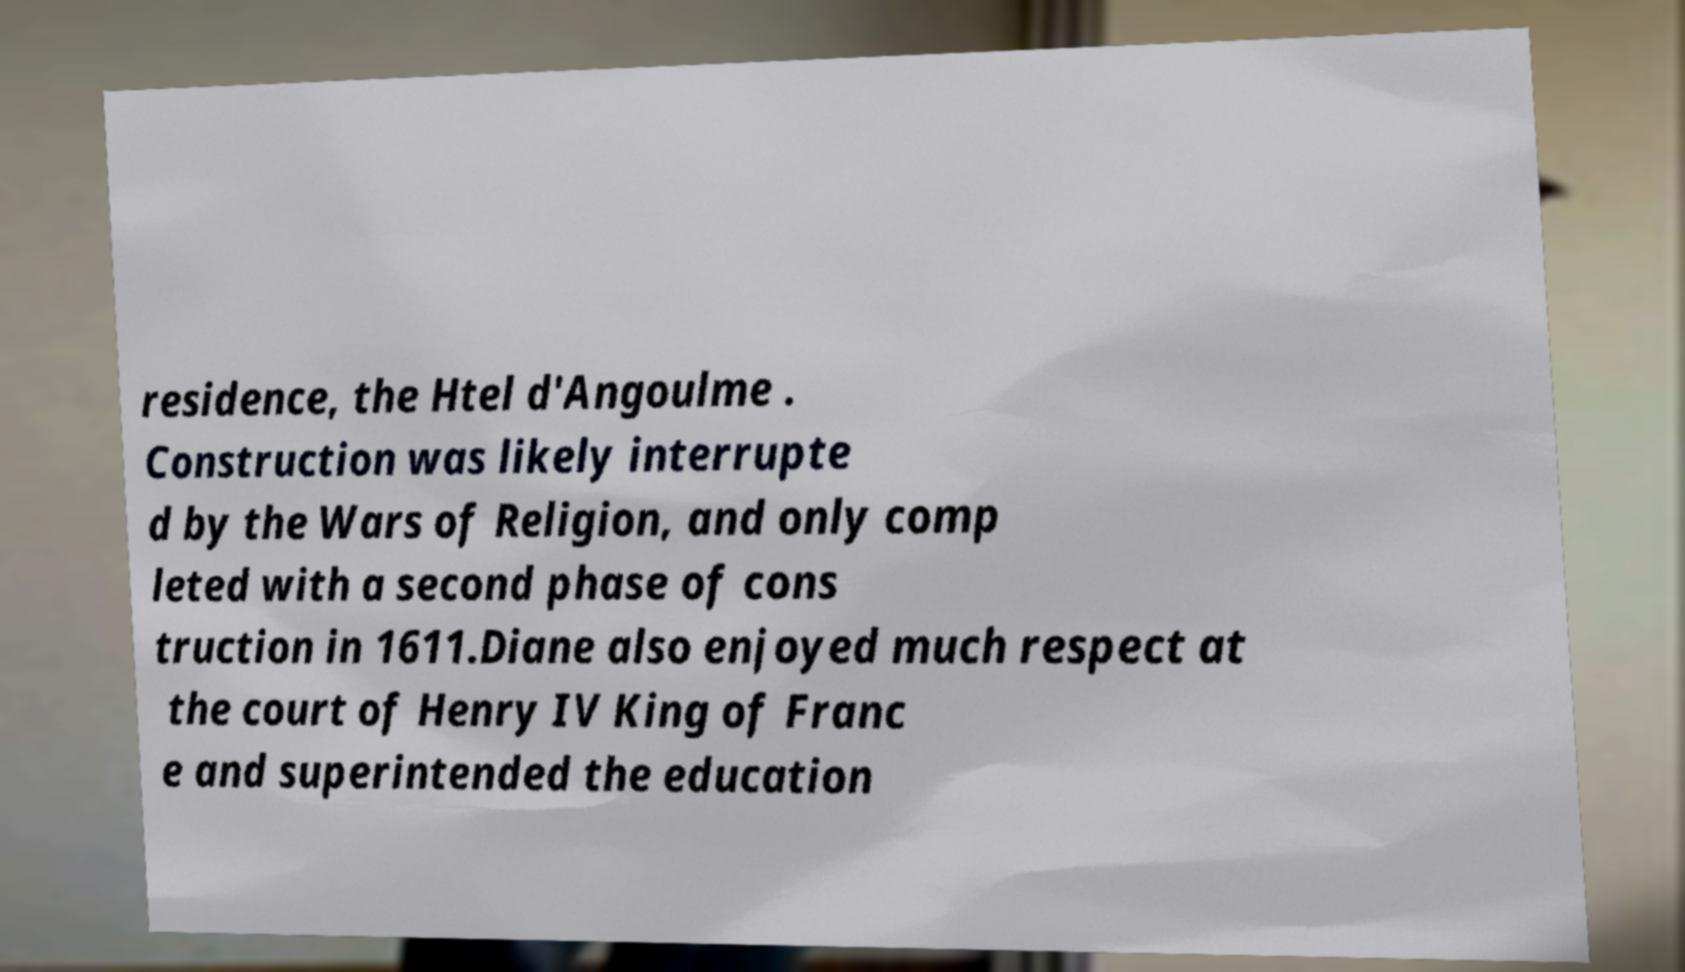Please identify and transcribe the text found in this image. residence, the Htel d'Angoulme . Construction was likely interrupte d by the Wars of Religion, and only comp leted with a second phase of cons truction in 1611.Diane also enjoyed much respect at the court of Henry IV King of Franc e and superintended the education 